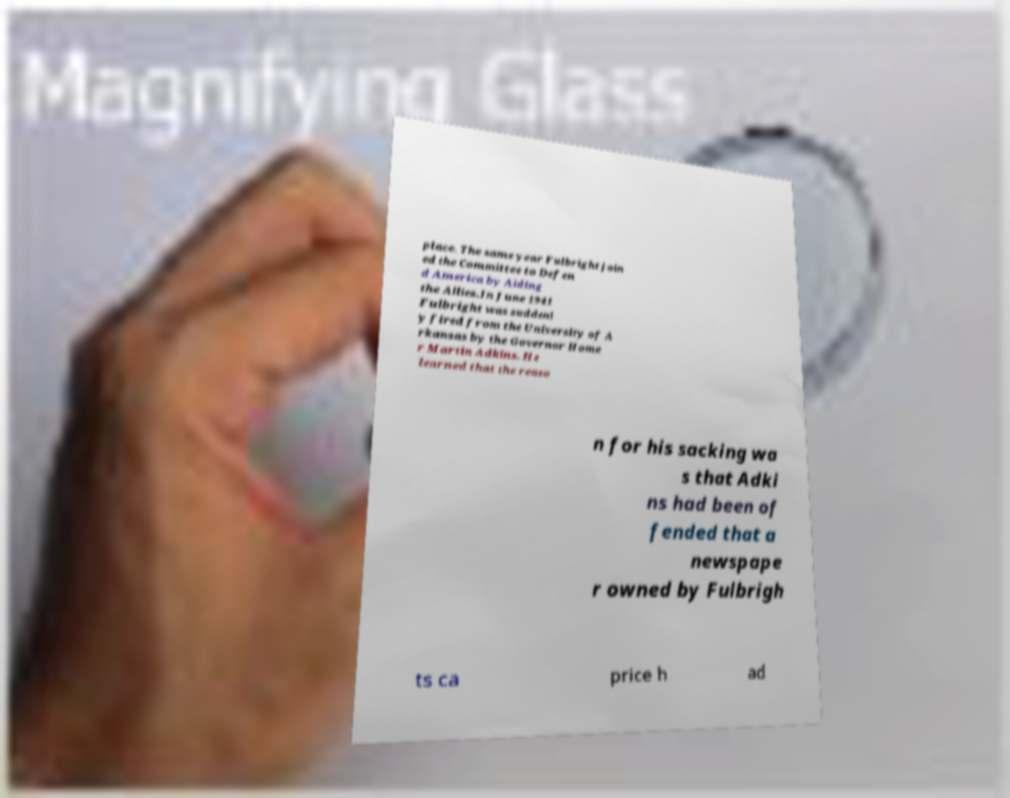Please read and relay the text visible in this image. What does it say? place. The same year Fulbright join ed the Committee to Defen d America by Aiding the Allies.In June 1941 Fulbright was suddenl y fired from the University of A rkansas by the Governor Home r Martin Adkins. He learned that the reaso n for his sacking wa s that Adki ns had been of fended that a newspape r owned by Fulbrigh ts ca price h ad 